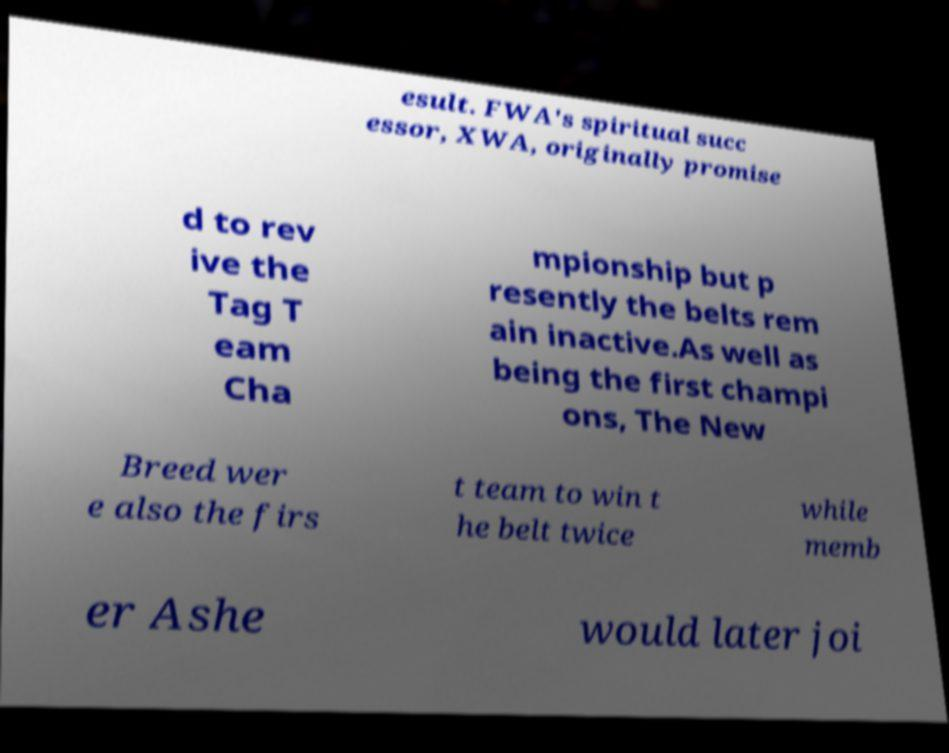Could you assist in decoding the text presented in this image and type it out clearly? esult. FWA's spiritual succ essor, XWA, originally promise d to rev ive the Tag T eam Cha mpionship but p resently the belts rem ain inactive.As well as being the first champi ons, The New Breed wer e also the firs t team to win t he belt twice while memb er Ashe would later joi 